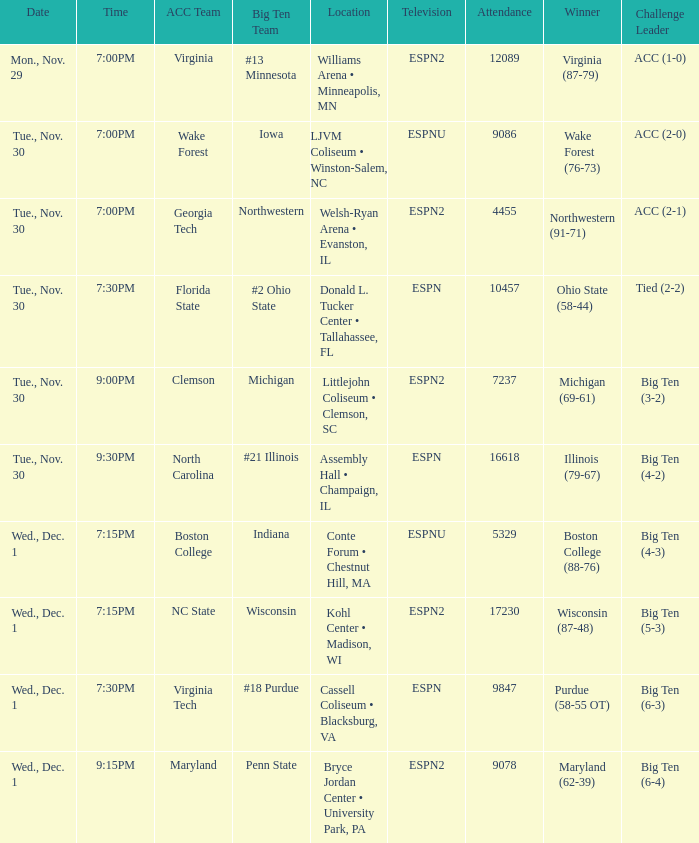Where did the games that had Wake Forest as Acc Team take place? LJVM Coliseum • Winston-Salem, NC. 